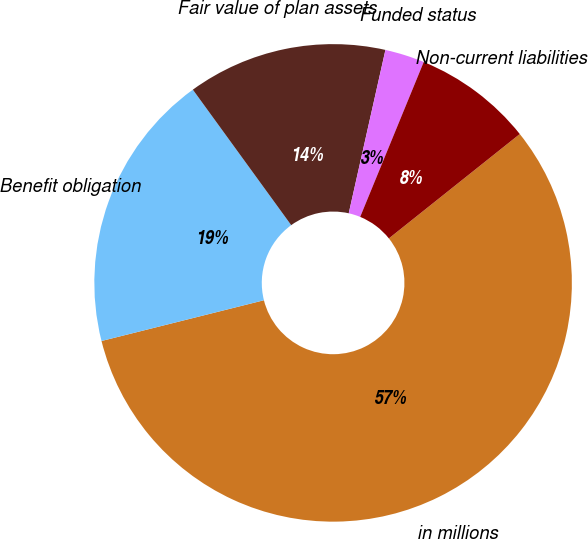Convert chart. <chart><loc_0><loc_0><loc_500><loc_500><pie_chart><fcel>in millions<fcel>Benefit obligation<fcel>Fair value of plan assets<fcel>Funded status<fcel>Non-current liabilities<nl><fcel>56.8%<fcel>18.92%<fcel>13.51%<fcel>2.68%<fcel>8.09%<nl></chart> 